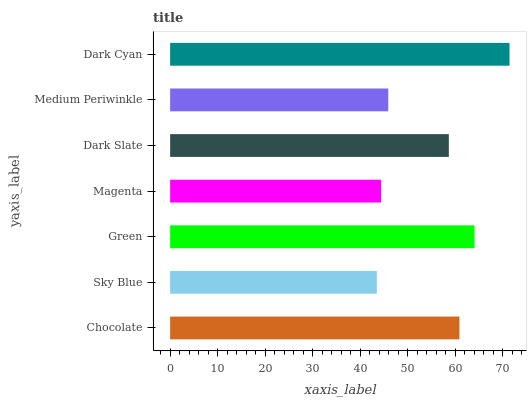Is Sky Blue the minimum?
Answer yes or no. Yes. Is Dark Cyan the maximum?
Answer yes or no. Yes. Is Green the minimum?
Answer yes or no. No. Is Green the maximum?
Answer yes or no. No. Is Green greater than Sky Blue?
Answer yes or no. Yes. Is Sky Blue less than Green?
Answer yes or no. Yes. Is Sky Blue greater than Green?
Answer yes or no. No. Is Green less than Sky Blue?
Answer yes or no. No. Is Dark Slate the high median?
Answer yes or no. Yes. Is Dark Slate the low median?
Answer yes or no. Yes. Is Sky Blue the high median?
Answer yes or no. No. Is Magenta the low median?
Answer yes or no. No. 